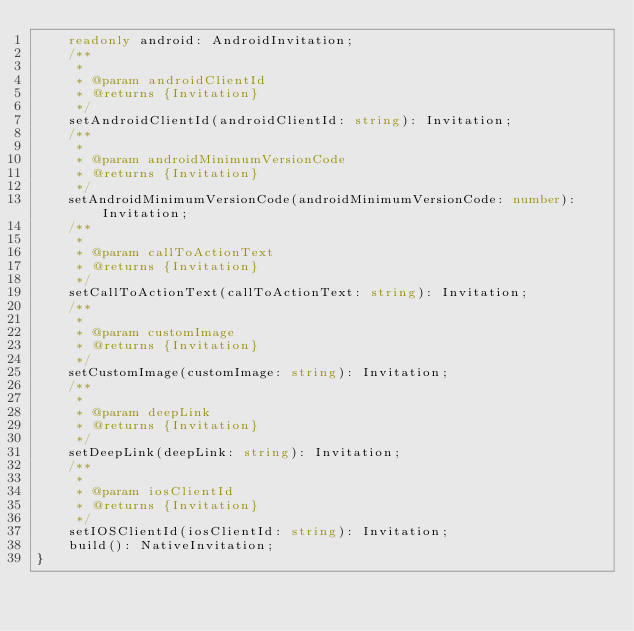<code> <loc_0><loc_0><loc_500><loc_500><_TypeScript_>    readonly android: AndroidInvitation;
    /**
     *
     * @param androidClientId
     * @returns {Invitation}
     */
    setAndroidClientId(androidClientId: string): Invitation;
    /**
     *
     * @param androidMinimumVersionCode
     * @returns {Invitation}
     */
    setAndroidMinimumVersionCode(androidMinimumVersionCode: number): Invitation;
    /**
     *
     * @param callToActionText
     * @returns {Invitation}
     */
    setCallToActionText(callToActionText: string): Invitation;
    /**
     *
     * @param customImage
     * @returns {Invitation}
     */
    setCustomImage(customImage: string): Invitation;
    /**
     *
     * @param deepLink
     * @returns {Invitation}
     */
    setDeepLink(deepLink: string): Invitation;
    /**
     *
     * @param iosClientId
     * @returns {Invitation}
     */
    setIOSClientId(iosClientId: string): Invitation;
    build(): NativeInvitation;
}
</code> 